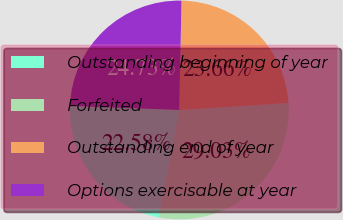Convert chart to OTSL. <chart><loc_0><loc_0><loc_500><loc_500><pie_chart><fcel>Outstanding beginning of year<fcel>Forfeited<fcel>Outstanding end of year<fcel>Options exercisable at year<nl><fcel>22.58%<fcel>29.03%<fcel>23.66%<fcel>24.73%<nl></chart> 